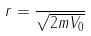Convert formula to latex. <formula><loc_0><loc_0><loc_500><loc_500>r = \frac { } { \sqrt { 2 m V _ { 0 } } }</formula> 